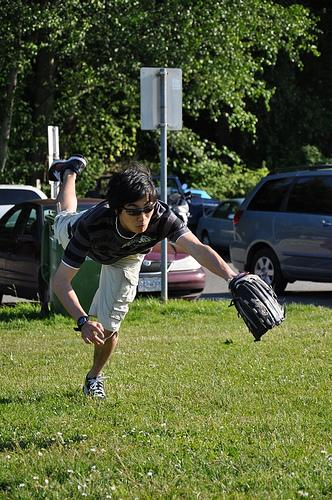What is on the man's face?
Quick response, please. Sunglasses. Is this person  professional baseball player?
Answer briefly. No. Is the person diving to catch a ball or have they simply lost their balance?
Concise answer only. Catch ball. 